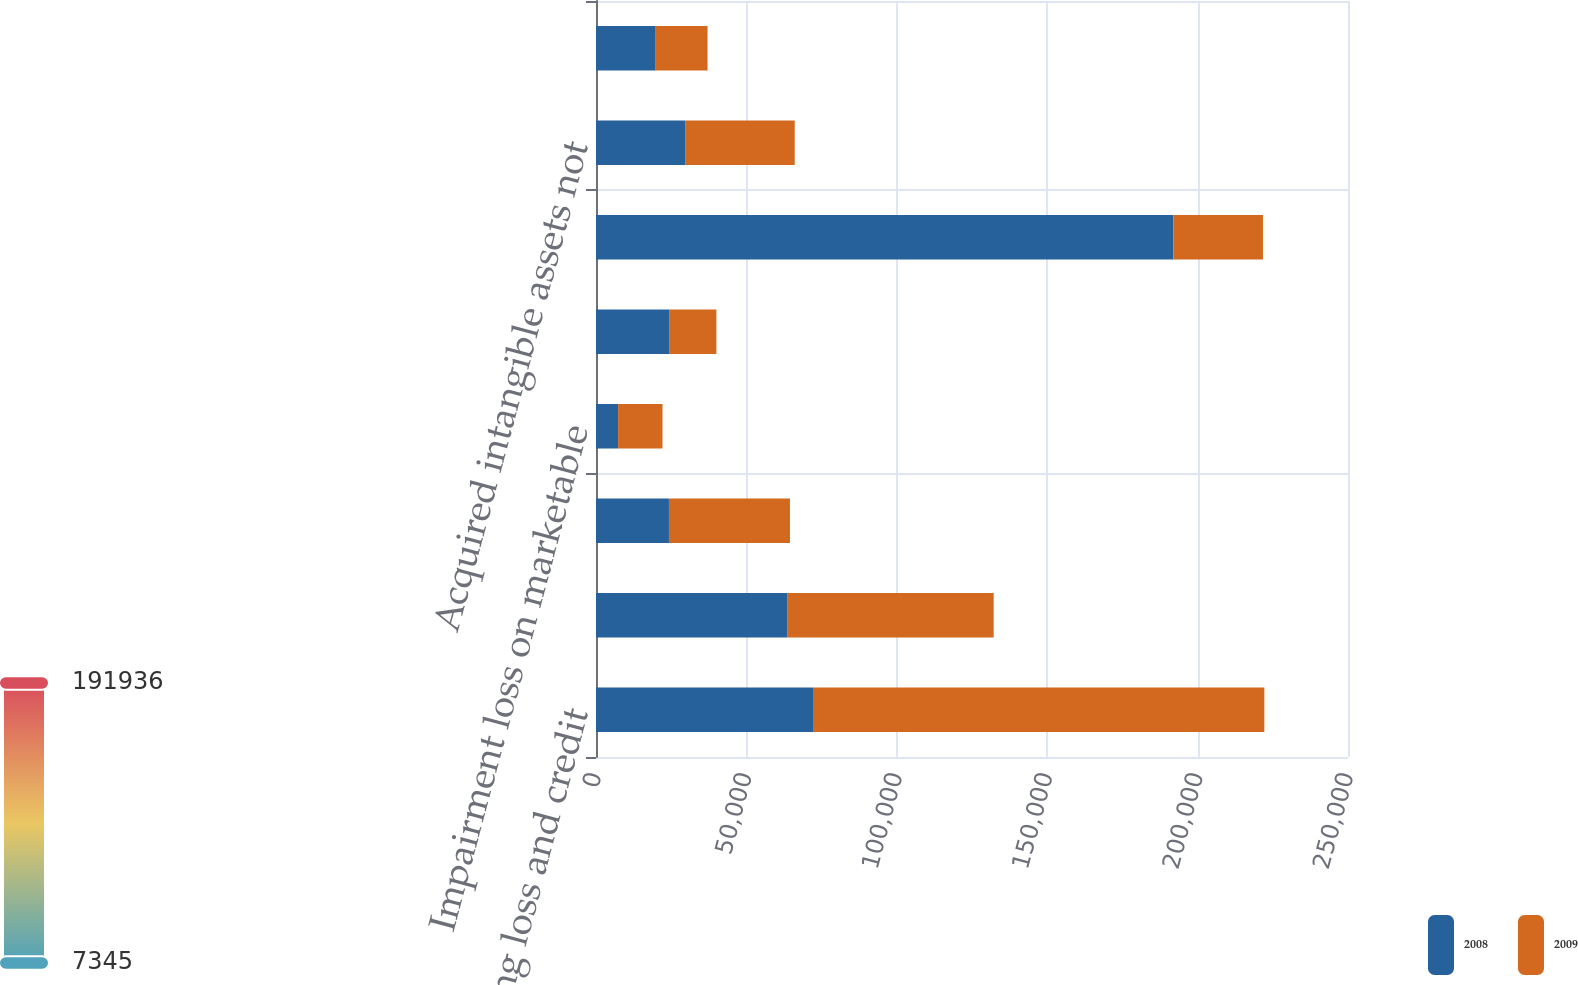Convert chart. <chart><loc_0><loc_0><loc_500><loc_500><stacked_bar_chart><ecel><fcel>Net operating loss and credit<fcel>Depreciation and amortization<fcel>Compensation costs<fcel>Impairment loss on marketable<fcel>Other<fcel>Deferred tax assets<fcel>Acquired intangible assets not<fcel>Internal-use software<nl><fcel>2008<fcel>72146<fcel>63709<fcel>24251<fcel>7345<fcel>24485<fcel>191936<fcel>29792<fcel>19632<nl><fcel>2009<fcel>150041<fcel>68502<fcel>40227<fcel>14767<fcel>15539<fcel>29792<fcel>36271<fcel>17449<nl></chart> 